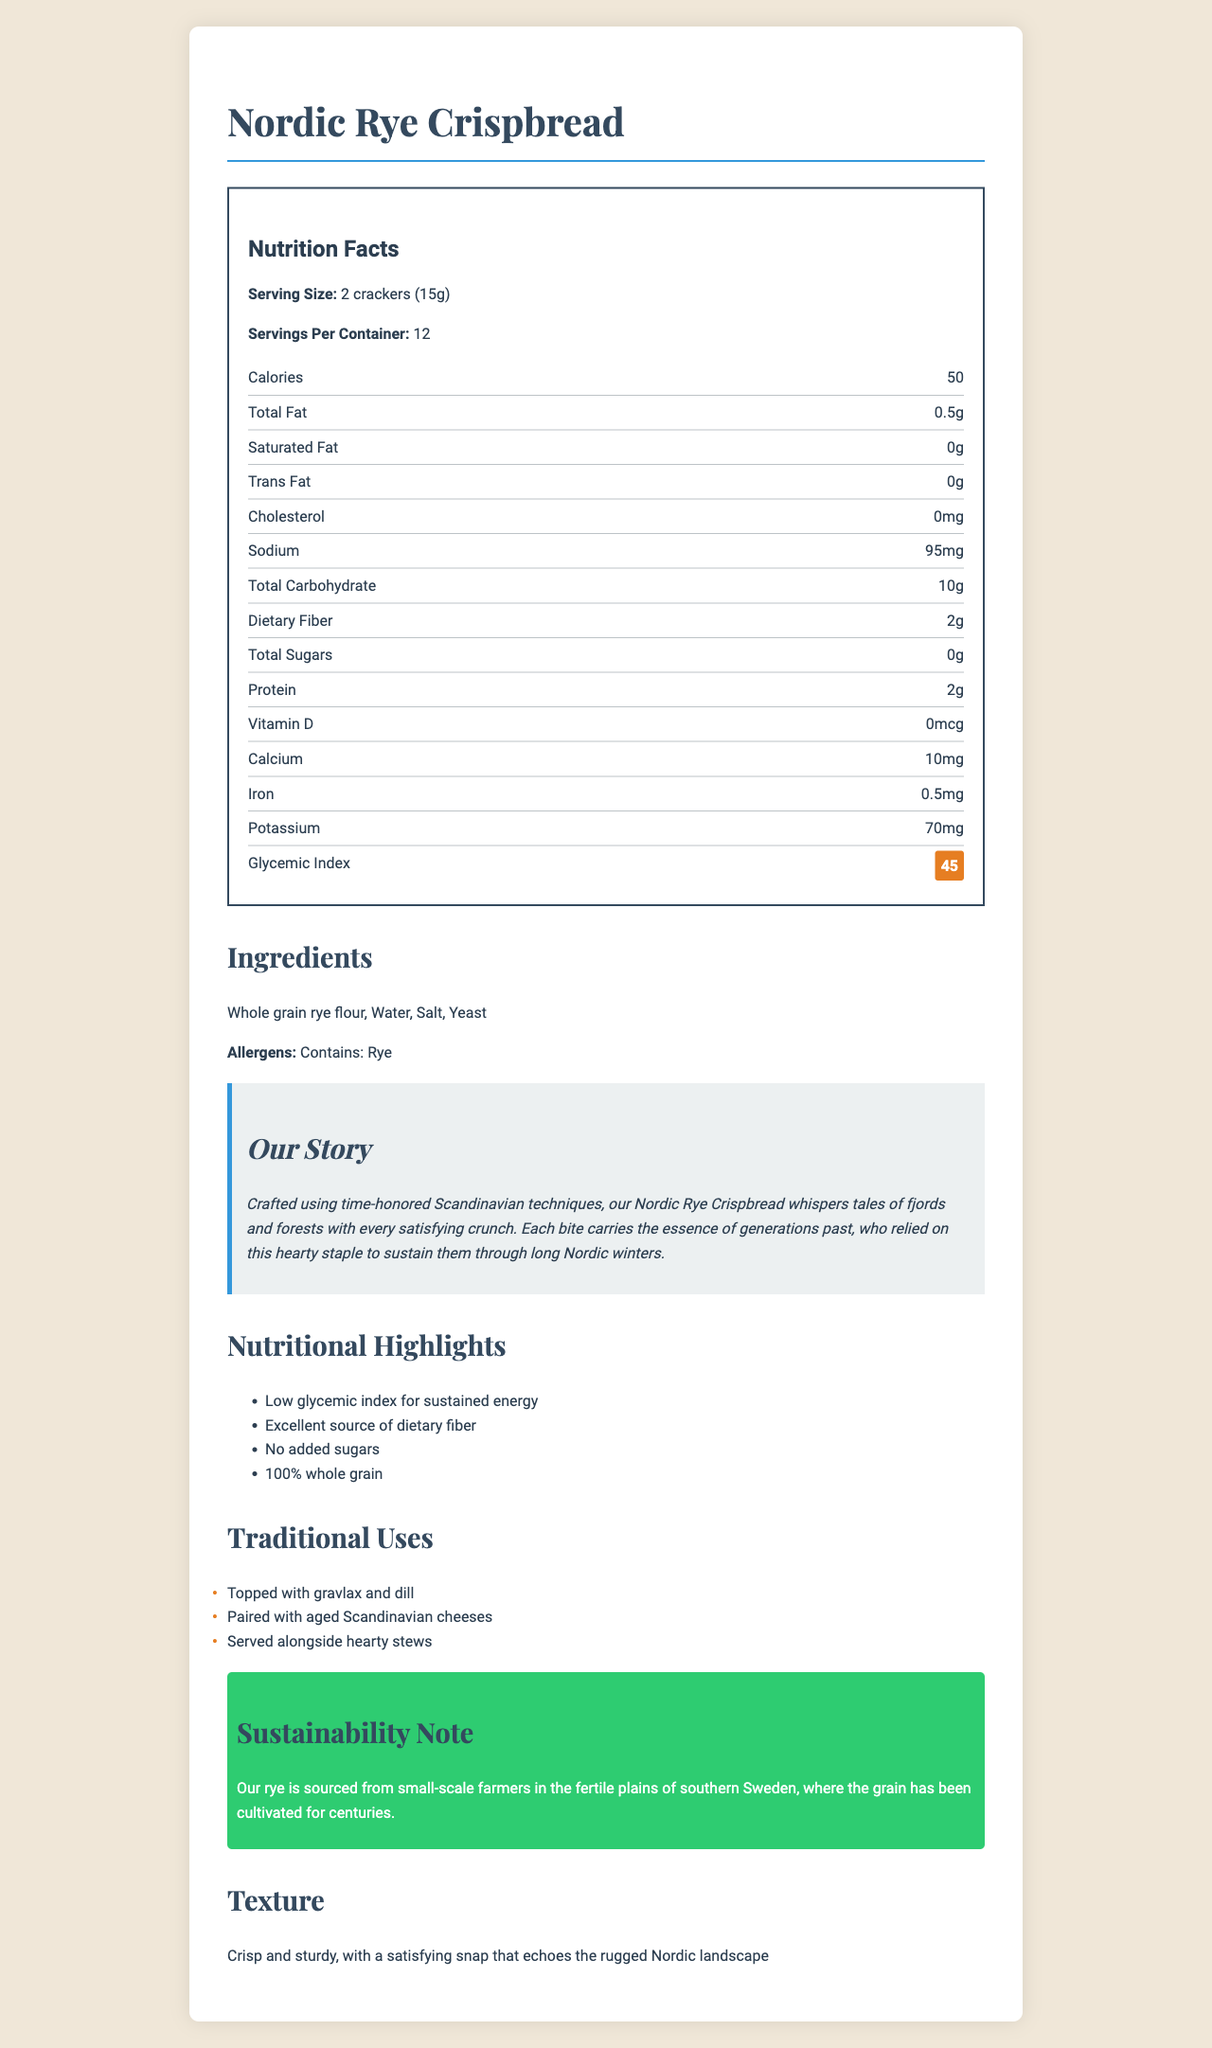what is the serving size of the Nordic Rye Crispbread? The serving size is listed at the beginning of the nutrition facts section.
Answer: 2 crackers (15g) how many calories are there per serving? The calorie count per serving is noted under the nutrition facts section.
Answer: 50 what is the glycemic index of this product? The glycemic index is highlighted in the nutrition facts section as a "highlight."
Answer: 45 which ingredient is listed first in the ingredients section? The first ingredient listed in the ingredients section is whole grain rye flour.
Answer: Whole grain rye flour how much dietary fiber does one serving of this crispbread provide? The amount of dietary fiber is listed in the nutrition facts section under dietary fiber.
Answer: 2g how much calcium is in a serving of this crispbread? The calcium content is given in the nutrition facts section under calcium.
Answer: 10mg what are two traditional uses for the Nordic Rye Crispbread? These traditional uses are listed in the traditional uses section.
Answer: 1. Topped with gravlax and dill 2. Paired with aged Scandinavian cheeses what is the main source of the rye for this crispbread? A. Large-scale farms in Norway B. Small-scale farmers in southern Sweden C. Urban farms in Denmark D. Large-scale farms in Finland The sustainability note specifies that the rye is sourced from small-scale farmers in southern Sweden.
Answer: B is there any added sugar in this product? One of the nutritional highlights states that there are no added sugars.
Answer: No does this product contain any allergens? The allergens section indicates that this product contains rye.
Answer: Yes describe the texture of the Nordic Rye Crispbread. The texture description is provided at the end of the document.
Answer: Crisp and sturdy, with a satisfying snap that echoes the rugged Nordic landscape summarize the main idea of the document. The document gives detailed nutrition facts, ingredients, brand story, nutritional highlights, traditional uses, and sustainability notes about the Nordic Rye Crispbread.
Answer: The Nordic Rye Crispbread is a traditional Scandinavian snack, known for its low glycemic index, high dietary fiber, and natural ingredients. It is crafted using time-honored techniques and sourced from small-scale farmers in Sweden. The product has no added sugars and is versatile in its traditional uses. how long have the techniques used to craft this product been in practice? The document mentions "time-honored Scandinavian techniques," but it does not specify exactly how long these techniques have been in practice.
Answer: Cannot be determined 